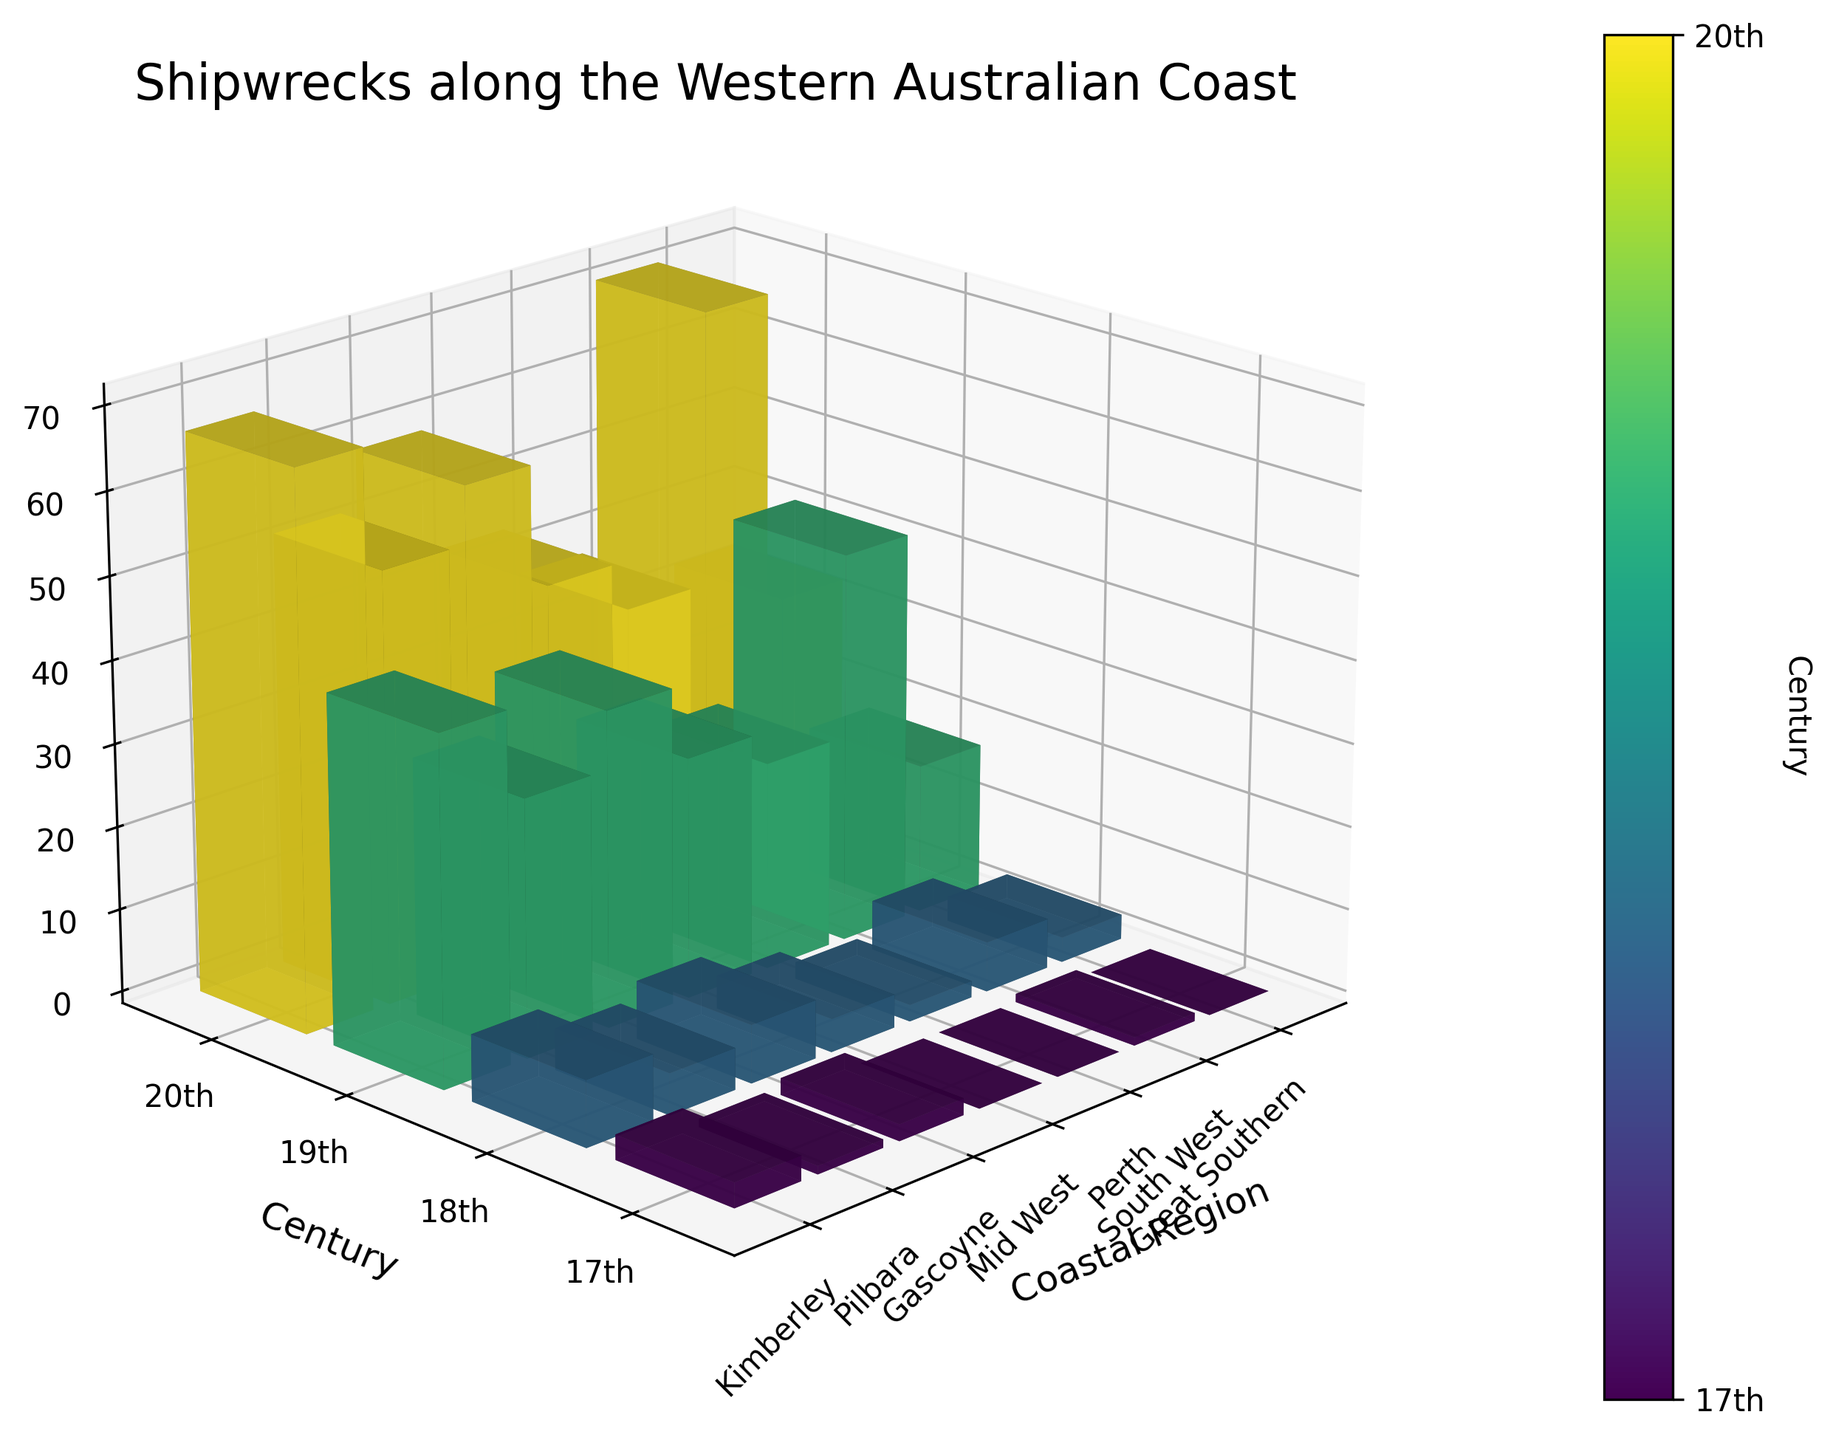What's the title of the figure? The title of the figure can be found at the top, typically using a larger font size than other text. In this figure, the title is written in a clear and noticeable way.
Answer: Shipwrecks along the Western Australian Coast What century has the highest number of shipwrecks overall? To find this, we need to observe the height of the bars for each coastal region within each century. The century with the tallest bars on average will indicate the highest number of shipwrecks. The 20th century bars are the tallest overall.
Answer: 20th Which coastal region had the most shipwrecks in the 18th century? Look at the 18th-century bars for each coastal region and identify the tallest bar, which represents the highest number of shipwrecks. The South West region has the tallest bar for the 18th century.
Answer: South West How many shipwrecks occurred in the Gascoyne region during the 19th century? Locate the bar representing the 19th century and the Gascoyne region, then observe the height of the bar, which indicates the number of shipwrecks. The height of the bar corresponding to the Gascoyne in the 19th century shows 38 shipwrecks.
Answer: 38 In which century did the Perth region have the fewest shipwrecks? Compare the height of the bars for Perth across all centuries. The 17th century has the shortest bar for Perth, indicating the fewest shipwrecks.
Answer: 17th Calculate the total number of shipwrecks in the South West region across all centuries. Add the number of shipwrecks in the South West region for each century: 1 (17th) + 6 (18th) + 47 (19th) + 71 (20th) = 125.
Answer: 125 Which had more shipwrecks in the 19th century: Pilbara or Perth? Compare the heights of the bars for the Pilbara and Perth regions in the 19th century. Pilbara's bar is taller, indicating it had more shipwrecks, with 31 compared to Perth's 25.
Answer: Pilbara How does the number of shipwrecks in the Great Southern region change from the 19th to the 20th century? Analyze the height of the bars representing the Great Southern region for the 19th and 20th centuries. The bar for the 20th century is taller, indicating an increase from 18 in the 19th century to 33 in the 20th century.
Answer: Increase What's the total number of shipwrecks for all regions combined in the 17th century? Add the number of shipwrecks for each coastal region in the 17th century: 3 (Kimberley) + 1 (Pilbara) + 2 (Gascoyne) + 0 (Mid West) + 0 (Perth) + 1 (South West) + 0 (Great Southern) = 7.
Answer: 7 Which century shows the largest increase in the number of shipwrecks compared to the previous century? First, calculate the total number of shipwrecks for each century: 7 (17th), 35 (18th), 230 (19th), 364 (20th). Then, determine the increase: 18th - 17th (28), 19th - 18th (195), 20th - 19th (134). The largest increase occurs from the 18th to the 19th century.
Answer: From 18th to 19th 